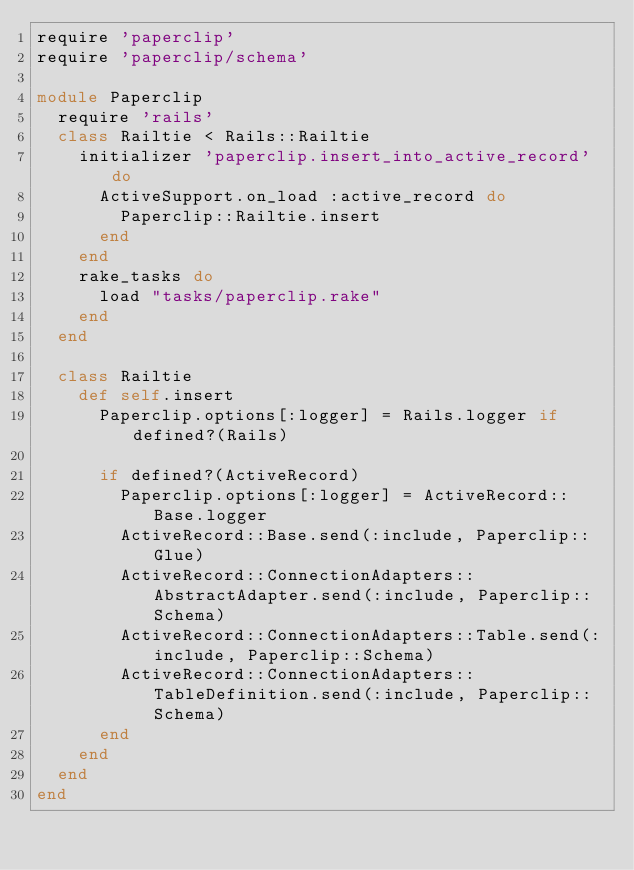<code> <loc_0><loc_0><loc_500><loc_500><_Ruby_>require 'paperclip'
require 'paperclip/schema'

module Paperclip
  require 'rails'
  class Railtie < Rails::Railtie
    initializer 'paperclip.insert_into_active_record' do
      ActiveSupport.on_load :active_record do
        Paperclip::Railtie.insert
      end
    end
    rake_tasks do
      load "tasks/paperclip.rake"
    end
  end

  class Railtie
    def self.insert
      Paperclip.options[:logger] = Rails.logger if defined?(Rails)

      if defined?(ActiveRecord)
        Paperclip.options[:logger] = ActiveRecord::Base.logger
        ActiveRecord::Base.send(:include, Paperclip::Glue)
        ActiveRecord::ConnectionAdapters::AbstractAdapter.send(:include, Paperclip::Schema)
        ActiveRecord::ConnectionAdapters::Table.send(:include, Paperclip::Schema)
        ActiveRecord::ConnectionAdapters::TableDefinition.send(:include, Paperclip::Schema)
      end
    end
  end
end
</code> 